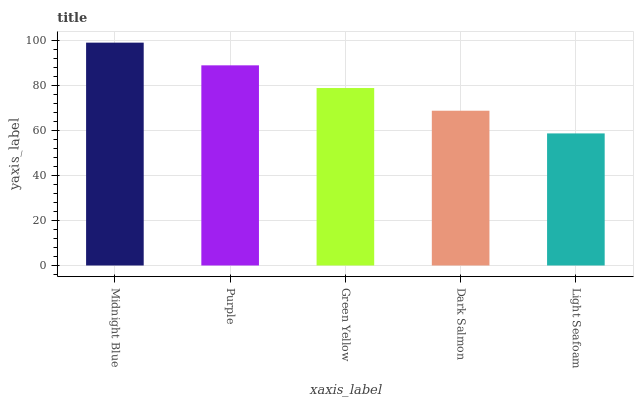Is Light Seafoam the minimum?
Answer yes or no. Yes. Is Midnight Blue the maximum?
Answer yes or no. Yes. Is Purple the minimum?
Answer yes or no. No. Is Purple the maximum?
Answer yes or no. No. Is Midnight Blue greater than Purple?
Answer yes or no. Yes. Is Purple less than Midnight Blue?
Answer yes or no. Yes. Is Purple greater than Midnight Blue?
Answer yes or no. No. Is Midnight Blue less than Purple?
Answer yes or no. No. Is Green Yellow the high median?
Answer yes or no. Yes. Is Green Yellow the low median?
Answer yes or no. Yes. Is Light Seafoam the high median?
Answer yes or no. No. Is Dark Salmon the low median?
Answer yes or no. No. 